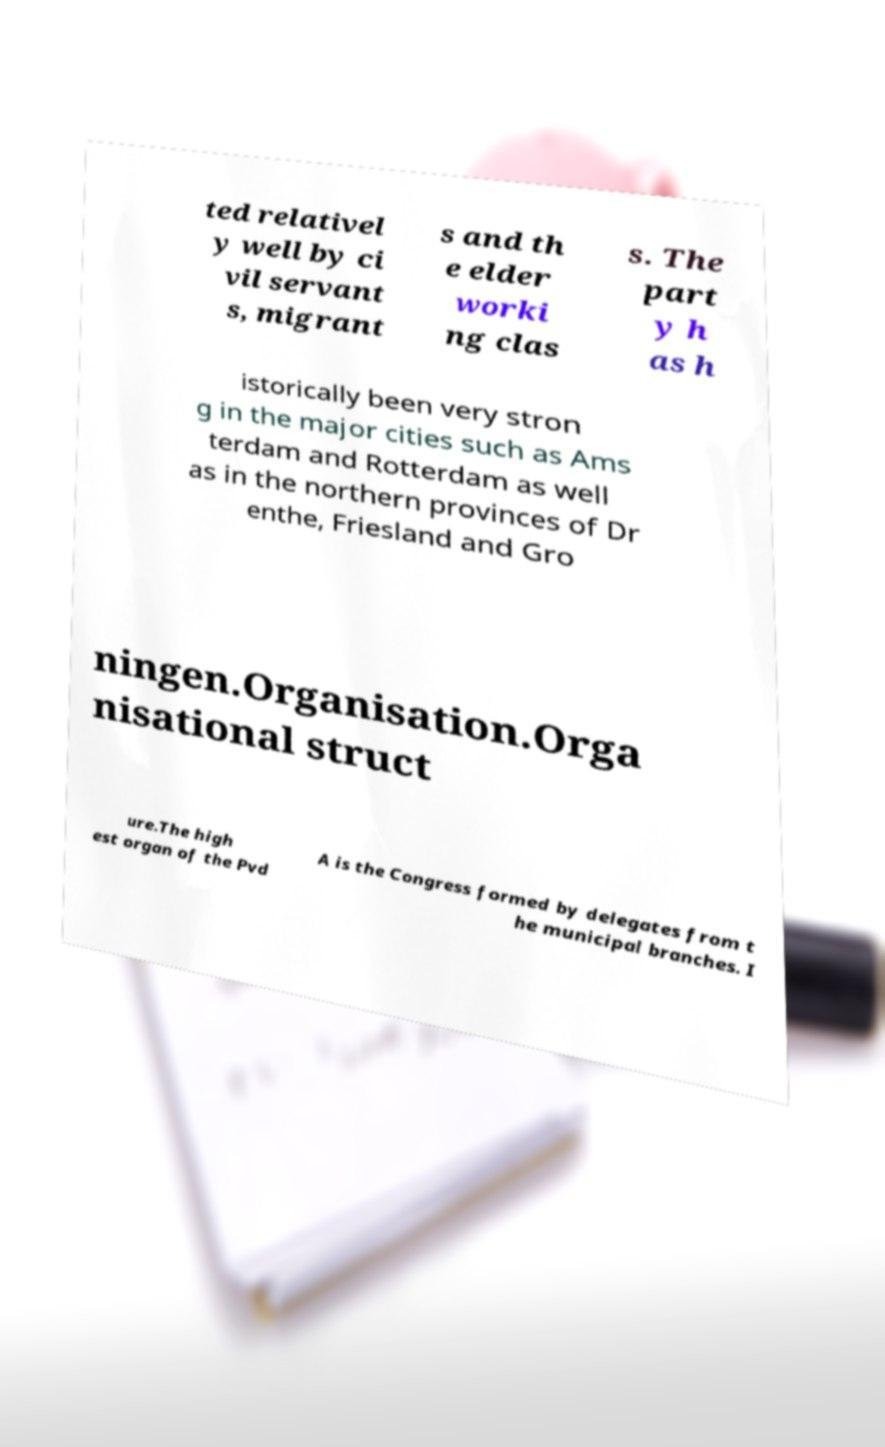What messages or text are displayed in this image? I need them in a readable, typed format. ted relativel y well by ci vil servant s, migrant s and th e elder worki ng clas s. The part y h as h istorically been very stron g in the major cities such as Ams terdam and Rotterdam as well as in the northern provinces of Dr enthe, Friesland and Gro ningen.Organisation.Orga nisational struct ure.The high est organ of the Pvd A is the Congress formed by delegates from t he municipal branches. I 